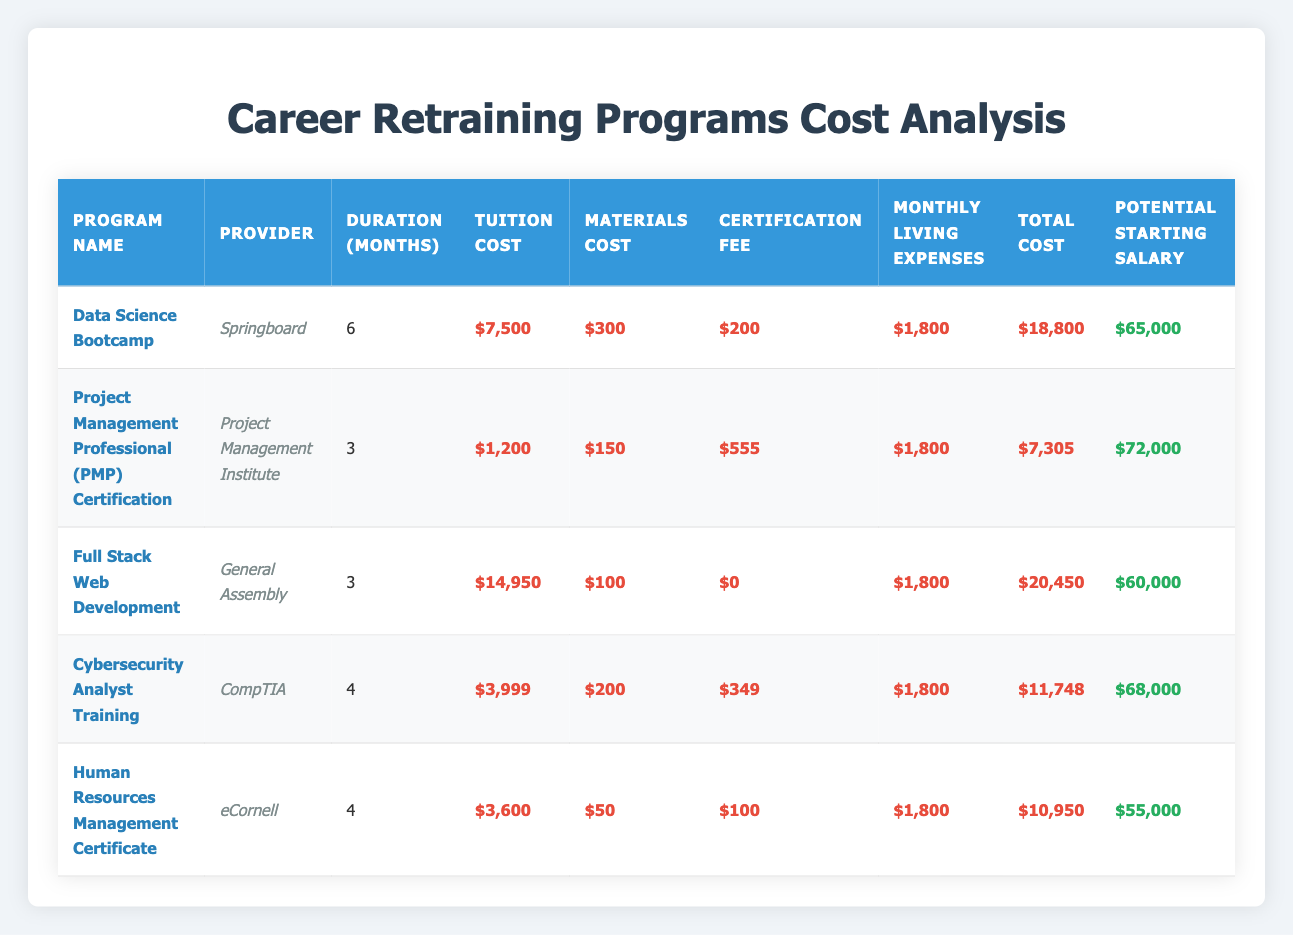What is the total cost of the Data Science Bootcamp? The table shows the tuition cost as $7,500, materials cost as $300, certification fee as $200, and estimated monthly living expenses for the 6-month duration as $1,800. The total cost is calculated as: $7,500 + $300 + $200 + (6 * $1,800) = $7,500 + $300 + $200 + $10,800 = $18,800.
Answer: $18,800 Which program has the highest potential starting salary? By reviewing the potential starting salaries listed in the table, the salaries are: Data Science Bootcamp: $65,000, PMP Certification: $72,000, Full Stack Web Development: $60,000, Cybersecurity Analyst Training: $68,000, and HR Management Certificate: $55,000. The highest among these is $72,000 from the PMP Certification.
Answer: PMP Certification: $72,000 Is the certification fee for the Full Stack Web Development program greater than that for the Cybersecurity Analyst Training? The certification fee for Full Stack Web Development is $0, while for Cybersecurity Analyst Training it is $349. Since $0 is not greater than $349, the answer is false.
Answer: No What is the average total cost of the retraining programs? The total costs as provided in the table are: $18,800 (Data Science Bootcamp), $7,305 (PMP Certification), $20,450 (Full Stack Web Development), $11,748 (Cybersecurity Analyst Training), and $10,950 (HR Management Certificate). Summing these gives $18,800 + $7,305 + $20,450 + $11,748 + $10,950 = $69,253. There are 5 programs, so the average total cost is $69,253 / 5 = $13,850.6, which can be rounded to $13,851.
Answer: $13,851 How much more expensive is the Data Science Bootcamp compared to the Cybersecurity Analyst Training? The total cost for the Data Science Bootcamp is $18,800, while for the Cybersecurity Analyst Training it is $11,748. To find the difference: $18,800 - $11,748 = $7,052. Therefore, the Data Science Bootcamp is $7,052 more expensive than the Cybersecurity Analyst Training.
Answer: $7,052 Is the duration of the Human Resources Management Certificate program longer than that of the PMP Certification? The duration for the HR Management Certificate is 4 months, while the PMP Certification is only 3 months. Since 4 months is greater than 3 months, the answer is yes.
Answer: Yes What are the potential starting salaries for programs that have a duration of 4 months or less? The programs with a duration of 4 months or less are: PMP Certification (3 months) with a salary of $72,000, Full Stack Web Development (3 months) with $60,000, and Cybersecurity Analyst Training (4 months) with $68,000. These three salaries can be listed accordingly.
Answer: $72,000, $60,000, $68,000 What is the total living expenses for all programs based on their duration? Living expenses are $1,800 per month and are calculated over each program’s duration. For the 5 programs, the expenses are: Data Science Bootcamp (6 months) = $10,800, PMP Certification (3 months) = $5,400, Full Stack Web Development (3 months) = $5,400, Cybersecurity Analyst Training (4 months) = $7,200, and HR Management Certificate (4 months) = $7,200. Totaling these gives $10,800 + $5,400 + $5,400 + $7,200 + $7,200 = $35,000.
Answer: $35,000 